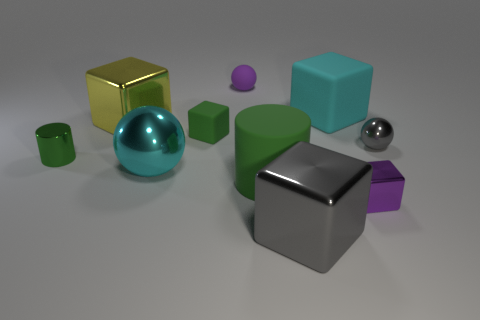There is a small rubber cube; is it the same color as the large shiny cube behind the gray cube?
Your response must be concise. No. Is there any other thing that has the same shape as the tiny gray shiny thing?
Ensure brevity in your answer.  Yes. What color is the cube that is left of the green rubber object behind the large green thing?
Give a very brief answer. Yellow. What number of small blue rubber objects are there?
Ensure brevity in your answer.  0. How many metallic things are either cyan balls or large gray objects?
Your response must be concise. 2. How many balls are the same color as the tiny metallic block?
Your answer should be compact. 1. What is the block that is behind the big yellow object to the left of the small green rubber object made of?
Keep it short and to the point. Rubber. The purple matte object is what size?
Your response must be concise. Small. How many green metallic cylinders are the same size as the purple metal object?
Give a very brief answer. 1. How many tiny purple matte objects are the same shape as the tiny green rubber object?
Provide a short and direct response. 0. 